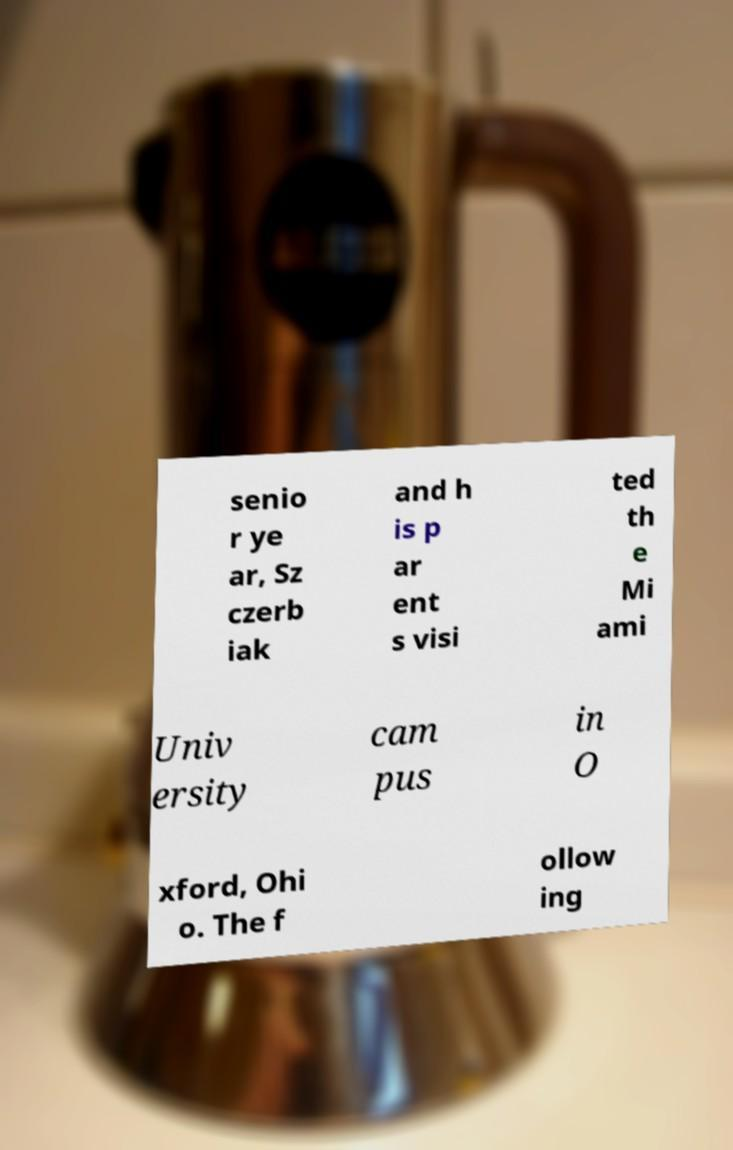For documentation purposes, I need the text within this image transcribed. Could you provide that? senio r ye ar, Sz czerb iak and h is p ar ent s visi ted th e Mi ami Univ ersity cam pus in O xford, Ohi o. The f ollow ing 